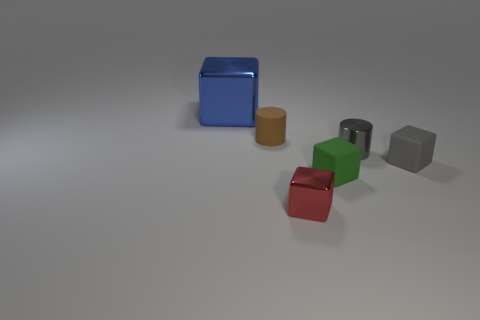How many things are small brown rubber things or metallic objects that are in front of the big blue shiny cube?
Give a very brief answer. 3. What is the color of the tiny cylinder to the left of the cylinder that is to the right of the metallic block that is in front of the blue cube?
Offer a very short reply. Brown. There is another tiny thing that is the same shape as the brown thing; what is it made of?
Your response must be concise. Metal. The large object has what color?
Your answer should be very brief. Blue. What number of metallic things are either small things or big blue cubes?
Make the answer very short. 3. Is there a big blue metallic cube right of the metallic cube on the right side of the metallic thing that is to the left of the tiny brown object?
Offer a terse response. No. There is a cube that is the same material as the large thing; what size is it?
Give a very brief answer. Small. There is a tiny green block; are there any small cubes behind it?
Give a very brief answer. Yes. There is a object that is on the left side of the tiny matte cylinder; is there a small gray metallic object that is right of it?
Give a very brief answer. Yes. There is a shiny thing that is in front of the gray shiny thing; is its size the same as the cylinder that is to the right of the tiny matte cylinder?
Make the answer very short. Yes. 